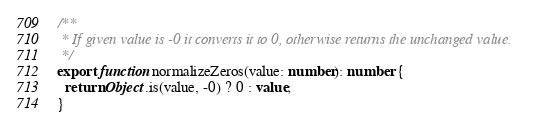Convert code to text. <code><loc_0><loc_0><loc_500><loc_500><_TypeScript_>/**
 * If given value is -0 it converts it to 0, otherwise returns the unchanged value.
 */
export function normalizeZeros(value: number): number {
  return Object.is(value, -0) ? 0 : value;
}

</code> 